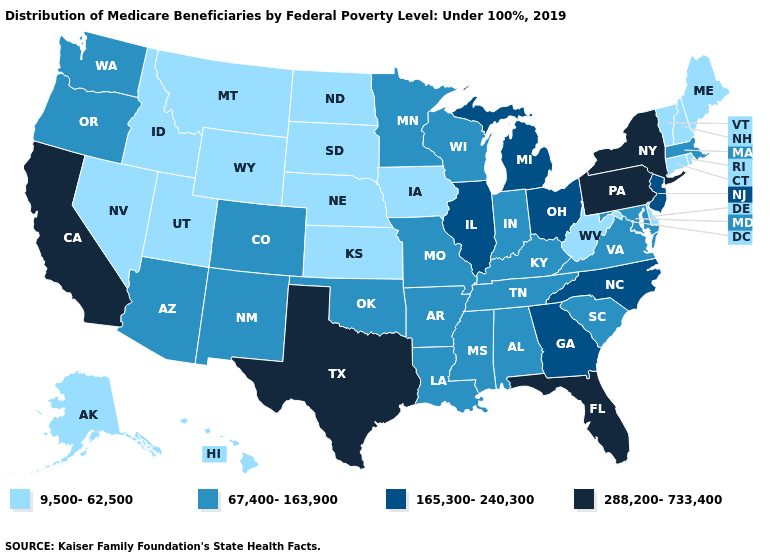What is the value of Alabama?
Concise answer only. 67,400-163,900. Name the states that have a value in the range 288,200-733,400?
Answer briefly. California, Florida, New York, Pennsylvania, Texas. Does Mississippi have a higher value than Montana?
Short answer required. Yes. Among the states that border Vermont , which have the lowest value?
Quick response, please. New Hampshire. Name the states that have a value in the range 165,300-240,300?
Keep it brief. Georgia, Illinois, Michigan, New Jersey, North Carolina, Ohio. What is the value of Massachusetts?
Give a very brief answer. 67,400-163,900. How many symbols are there in the legend?
Keep it brief. 4. Name the states that have a value in the range 9,500-62,500?
Write a very short answer. Alaska, Connecticut, Delaware, Hawaii, Idaho, Iowa, Kansas, Maine, Montana, Nebraska, Nevada, New Hampshire, North Dakota, Rhode Island, South Dakota, Utah, Vermont, West Virginia, Wyoming. Name the states that have a value in the range 288,200-733,400?
Quick response, please. California, Florida, New York, Pennsylvania, Texas. What is the value of Kentucky?
Quick response, please. 67,400-163,900. Name the states that have a value in the range 165,300-240,300?
Quick response, please. Georgia, Illinois, Michigan, New Jersey, North Carolina, Ohio. Among the states that border Washington , does Oregon have the highest value?
Short answer required. Yes. Name the states that have a value in the range 288,200-733,400?
Write a very short answer. California, Florida, New York, Pennsylvania, Texas. Does the map have missing data?
Be succinct. No. Name the states that have a value in the range 165,300-240,300?
Be succinct. Georgia, Illinois, Michigan, New Jersey, North Carolina, Ohio. 